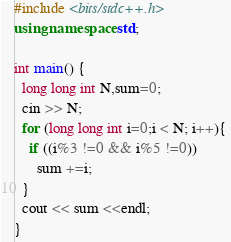Convert code to text. <code><loc_0><loc_0><loc_500><loc_500><_C++_>#include <bits/stdc++.h>
using namespace std;
 
int main() {
  long long int N,sum=0;
  cin >> N;
  for (long long int i=0;i < N; i++){ 
    if ((i%3 !=0 && i%5 !=0))
      sum +=i;
  }
  cout << sum <<endl;
}</code> 